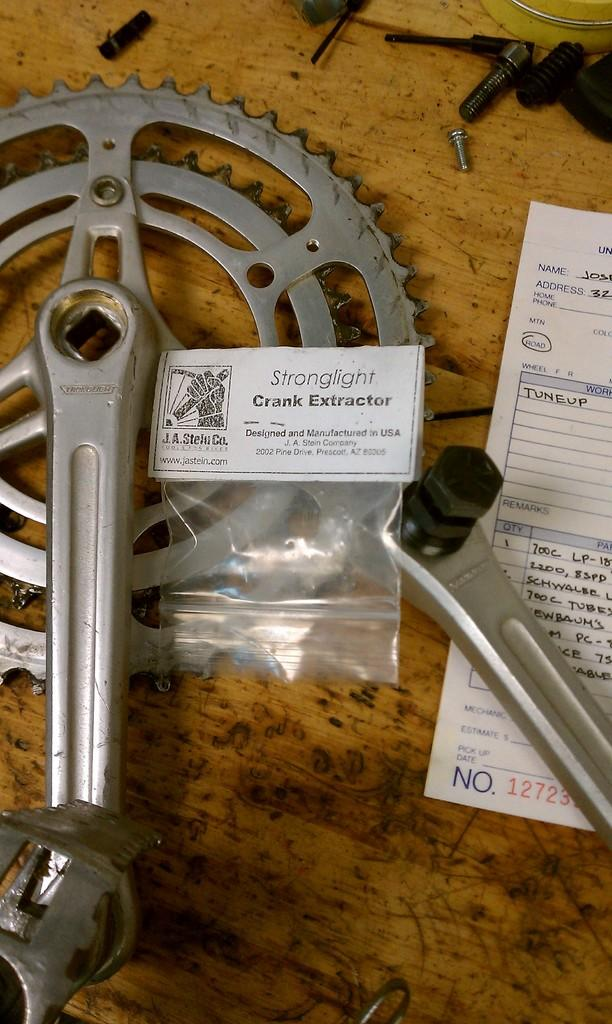What is the main object in the image that has a chain attached to it? There is a pedal with a chain in the image. What is covering the pedal with a chain in the image? There is a cover in the image. What type of items can be seen in the image that are typically used for fixing or assembling things? There are tools in the image. What type of food item is present in the image? There are nuts in the image. What type of paper item is present in the image? There is a paper in the image. Where are all these items placed in the image? All of these items are placed on a table. How many legs does the mailbox have in the image? There is no mailbox present in the image. What type of growth can be seen on the pedal with a chain in the image? There is no growth visible on the pedal with a chain in the image. 